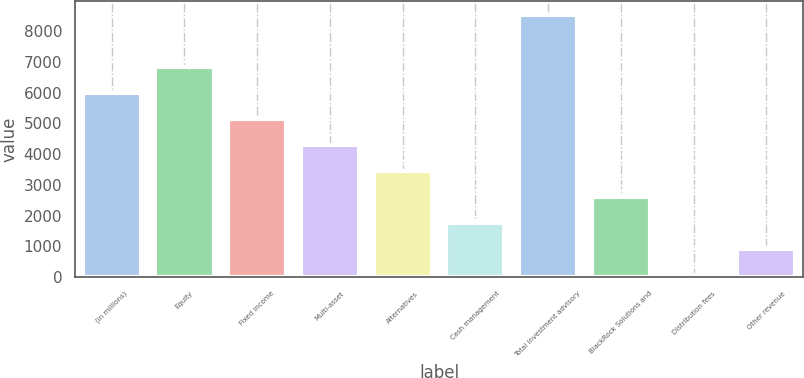Convert chart. <chart><loc_0><loc_0><loc_500><loc_500><bar_chart><fcel>(in millions)<fcel>Equity<fcel>Fixed income<fcel>Multi-asset<fcel>Alternatives<fcel>Cash management<fcel>Total investment advisory<fcel>BlackRock Solutions and<fcel>Distribution fees<fcel>Other revenue<nl><fcel>5995.8<fcel>6842.2<fcel>5149.4<fcel>4303<fcel>3456.6<fcel>1763.8<fcel>8535<fcel>2610.2<fcel>71<fcel>917.4<nl></chart> 